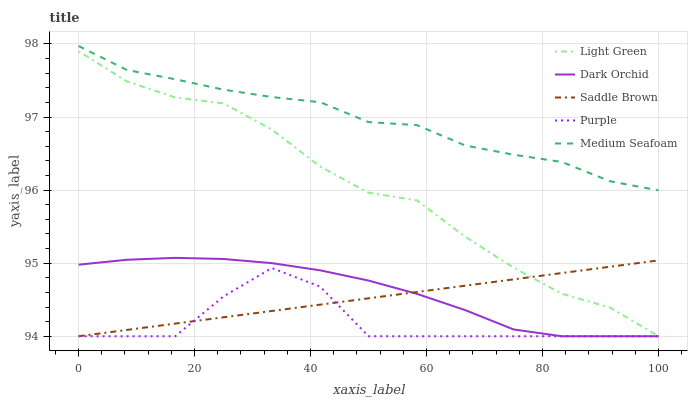Does Purple have the minimum area under the curve?
Answer yes or no. Yes. Does Medium Seafoam have the maximum area under the curve?
Answer yes or no. Yes. Does Dark Orchid have the minimum area under the curve?
Answer yes or no. No. Does Dark Orchid have the maximum area under the curve?
Answer yes or no. No. Is Saddle Brown the smoothest?
Answer yes or no. Yes. Is Purple the roughest?
Answer yes or no. Yes. Is Medium Seafoam the smoothest?
Answer yes or no. No. Is Medium Seafoam the roughest?
Answer yes or no. No. Does Purple have the lowest value?
Answer yes or no. Yes. Does Medium Seafoam have the lowest value?
Answer yes or no. No. Does Medium Seafoam have the highest value?
Answer yes or no. Yes. Does Dark Orchid have the highest value?
Answer yes or no. No. Is Light Green less than Medium Seafoam?
Answer yes or no. Yes. Is Medium Seafoam greater than Purple?
Answer yes or no. Yes. Does Light Green intersect Saddle Brown?
Answer yes or no. Yes. Is Light Green less than Saddle Brown?
Answer yes or no. No. Is Light Green greater than Saddle Brown?
Answer yes or no. No. Does Light Green intersect Medium Seafoam?
Answer yes or no. No. 